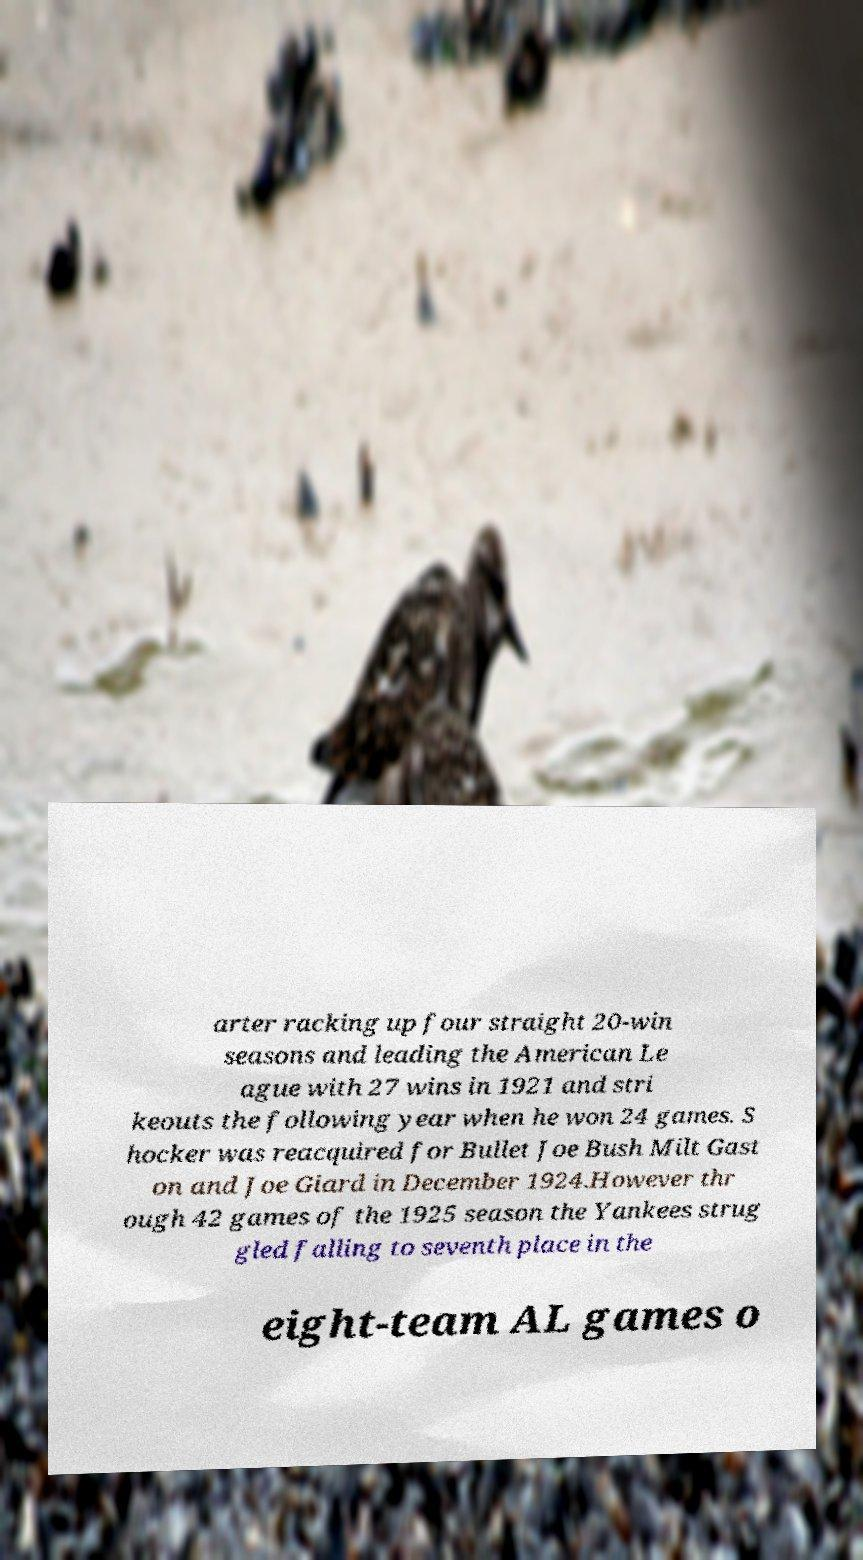What messages or text are displayed in this image? I need them in a readable, typed format. arter racking up four straight 20-win seasons and leading the American Le ague with 27 wins in 1921 and stri keouts the following year when he won 24 games. S hocker was reacquired for Bullet Joe Bush Milt Gast on and Joe Giard in December 1924.However thr ough 42 games of the 1925 season the Yankees strug gled falling to seventh place in the eight-team AL games o 